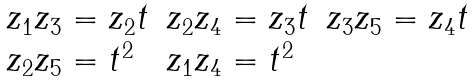Convert formula to latex. <formula><loc_0><loc_0><loc_500><loc_500>\begin{array} { l l l } z _ { 1 } z _ { 3 } = z _ { 2 } t & z _ { 2 } z _ { 4 } = z _ { 3 } t & z _ { 3 } z _ { 5 } = z _ { 4 } t \\ z _ { 2 } z _ { 5 } = t ^ { 2 } & z _ { 1 } z _ { 4 } = t ^ { 2 } & \end{array}</formula> 